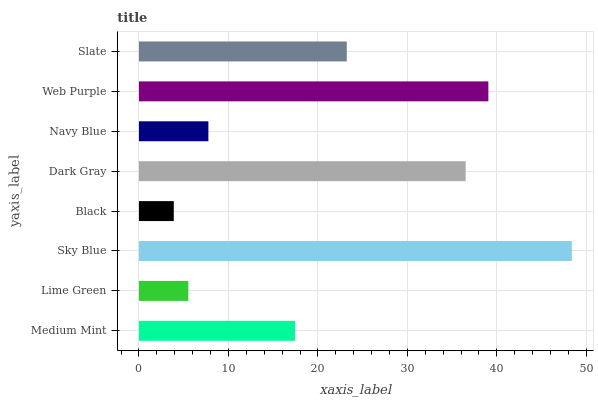Is Black the minimum?
Answer yes or no. Yes. Is Sky Blue the maximum?
Answer yes or no. Yes. Is Lime Green the minimum?
Answer yes or no. No. Is Lime Green the maximum?
Answer yes or no. No. Is Medium Mint greater than Lime Green?
Answer yes or no. Yes. Is Lime Green less than Medium Mint?
Answer yes or no. Yes. Is Lime Green greater than Medium Mint?
Answer yes or no. No. Is Medium Mint less than Lime Green?
Answer yes or no. No. Is Slate the high median?
Answer yes or no. Yes. Is Medium Mint the low median?
Answer yes or no. Yes. Is Medium Mint the high median?
Answer yes or no. No. Is Lime Green the low median?
Answer yes or no. No. 